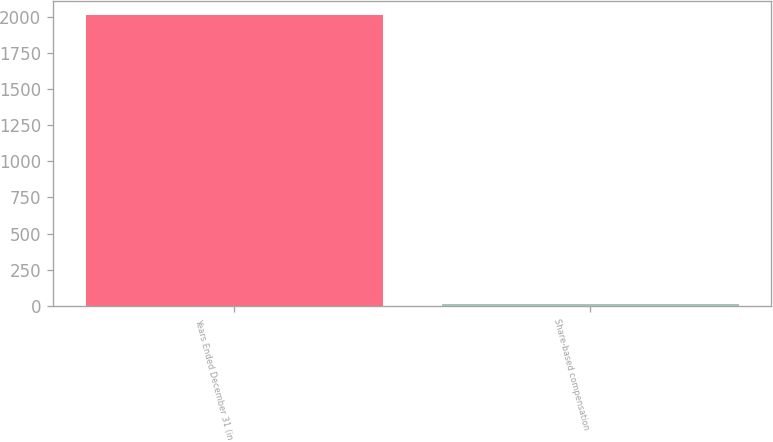<chart> <loc_0><loc_0><loc_500><loc_500><bar_chart><fcel>Years Ended December 31 (in<fcel>Share-based compensation<nl><fcel>2011<fcel>10<nl></chart> 